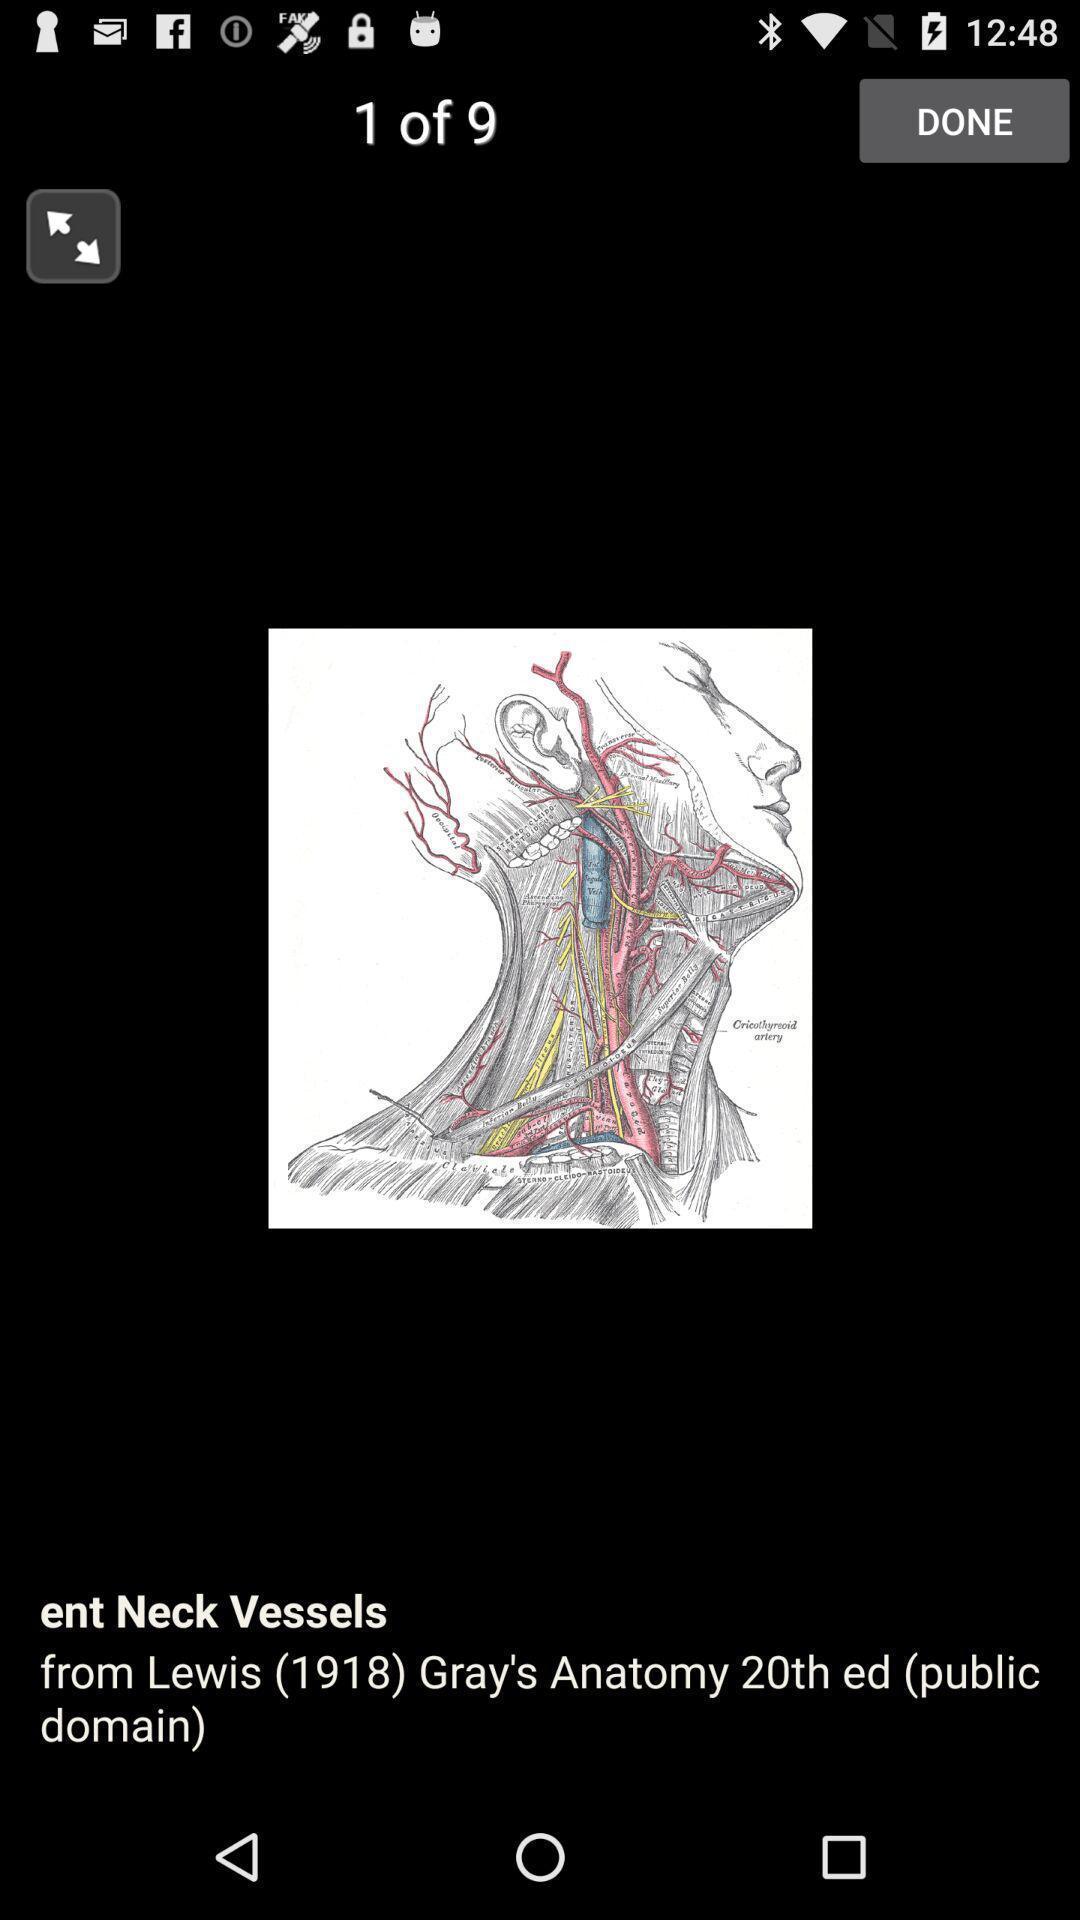Describe the key features of this screenshot. Screen showing neck vessels image. 